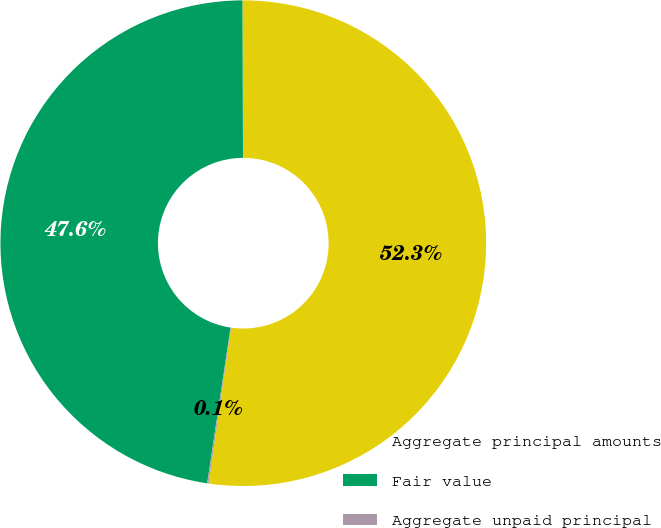<chart> <loc_0><loc_0><loc_500><loc_500><pie_chart><fcel>Aggregate principal amounts<fcel>Fair value<fcel>Aggregate unpaid principal<nl><fcel>52.34%<fcel>47.57%<fcel>0.09%<nl></chart> 